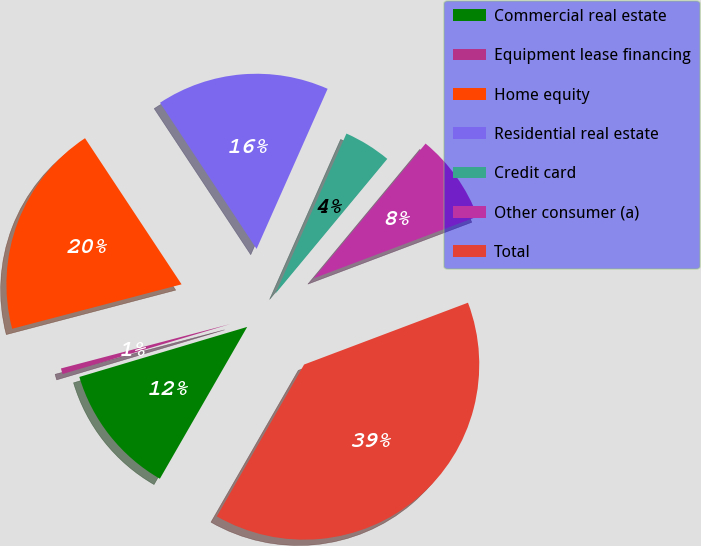<chart> <loc_0><loc_0><loc_500><loc_500><pie_chart><fcel>Commercial real estate<fcel>Equipment lease financing<fcel>Home equity<fcel>Residential real estate<fcel>Credit card<fcel>Other consumer (a)<fcel>Total<nl><fcel>12.08%<fcel>0.53%<fcel>19.79%<fcel>15.94%<fcel>4.38%<fcel>8.23%<fcel>39.05%<nl></chart> 